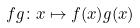Convert formula to latex. <formula><loc_0><loc_0><loc_500><loc_500>f g \colon x \mapsto f ( x ) g ( x )</formula> 